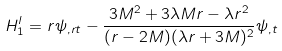Convert formula to latex. <formula><loc_0><loc_0><loc_500><loc_500>H _ { 1 } ^ { l } = r \psi _ { , r t } - \frac { 3 M ^ { 2 } + 3 \lambda M r - \lambda r ^ { 2 } } { ( r - 2 M ) ( \lambda r + 3 M ) ^ { 2 } } \psi _ { , t }</formula> 